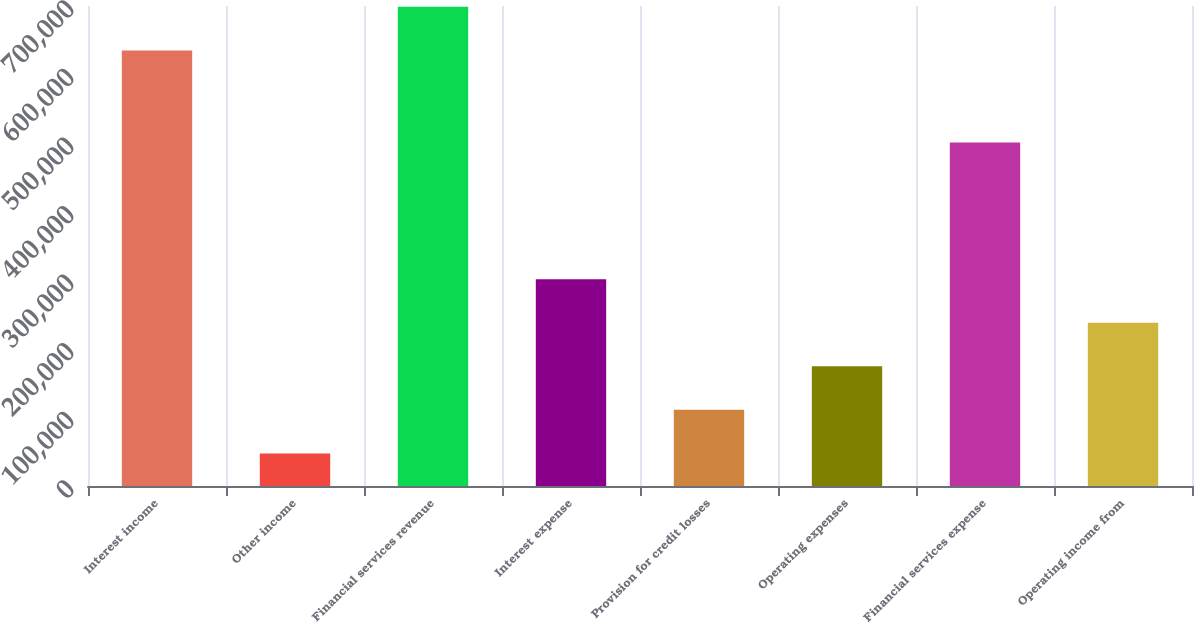Convert chart. <chart><loc_0><loc_0><loc_500><loc_500><bar_chart><fcel>Interest income<fcel>Other income<fcel>Financial services revenue<fcel>Interest expense<fcel>Provision for credit losses<fcel>Operating expenses<fcel>Financial services expense<fcel>Operating income from<nl><fcel>635207<fcel>47502<fcel>698728<fcel>301585<fcel>111023<fcel>174543<fcel>500836<fcel>238064<nl></chart> 